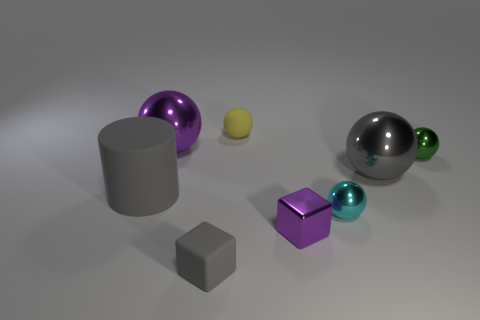Subtract all gray spheres. How many spheres are left? 4 Subtract all big gray spheres. How many spheres are left? 4 Subtract all red spheres. Subtract all purple cylinders. How many spheres are left? 5 Add 1 large yellow cylinders. How many objects exist? 9 Subtract all cylinders. How many objects are left? 7 Add 2 big gray things. How many big gray things exist? 4 Subtract 0 blue balls. How many objects are left? 8 Subtract all brown matte cubes. Subtract all small gray things. How many objects are left? 7 Add 2 big purple balls. How many big purple balls are left? 3 